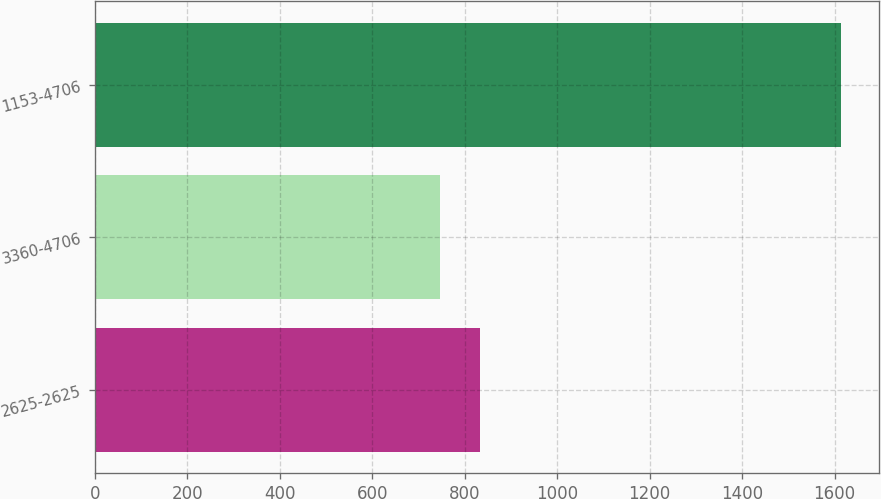Convert chart to OTSL. <chart><loc_0><loc_0><loc_500><loc_500><bar_chart><fcel>2625-2625<fcel>3360-4706<fcel>1153-4706<nl><fcel>832.9<fcel>746<fcel>1615<nl></chart> 